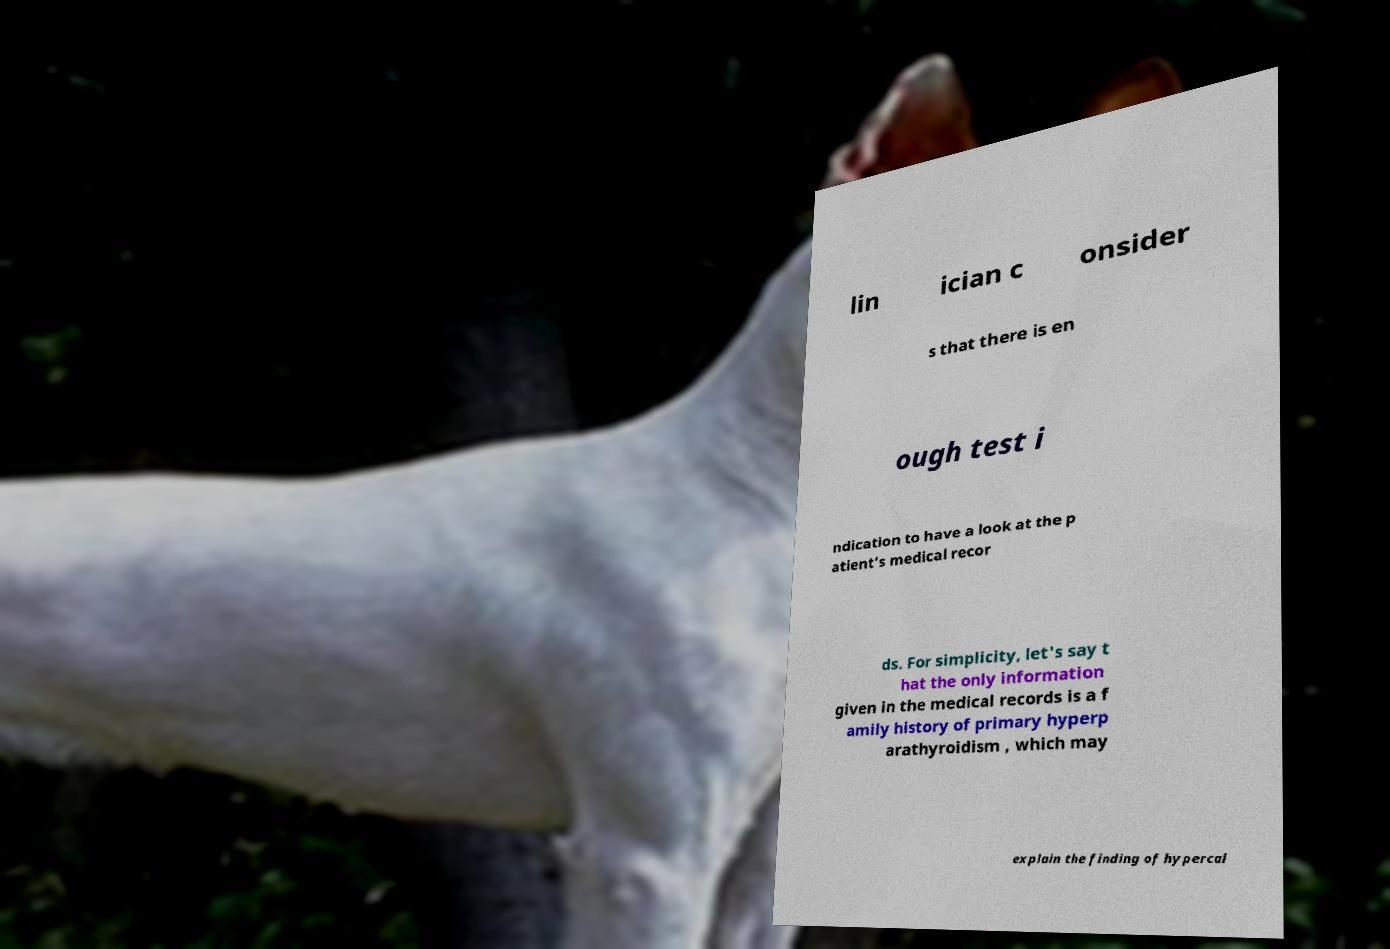Could you extract and type out the text from this image? lin ician c onsider s that there is en ough test i ndication to have a look at the p atient's medical recor ds. For simplicity, let's say t hat the only information given in the medical records is a f amily history of primary hyperp arathyroidism , which may explain the finding of hypercal 